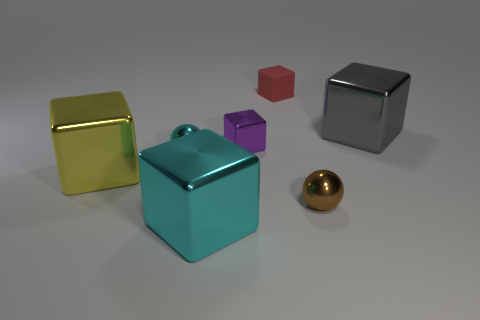Subtract all gray blocks. How many blocks are left? 4 Subtract all rubber blocks. How many blocks are left? 4 Subtract 1 blocks. How many blocks are left? 4 Subtract all red cubes. Subtract all cyan cylinders. How many cubes are left? 4 Add 1 metallic balls. How many objects exist? 8 Subtract all spheres. How many objects are left? 5 Subtract all red objects. Subtract all big cyan objects. How many objects are left? 5 Add 3 brown metallic objects. How many brown metallic objects are left? 4 Add 3 gray rubber cubes. How many gray rubber cubes exist? 3 Subtract 1 cyan balls. How many objects are left? 6 